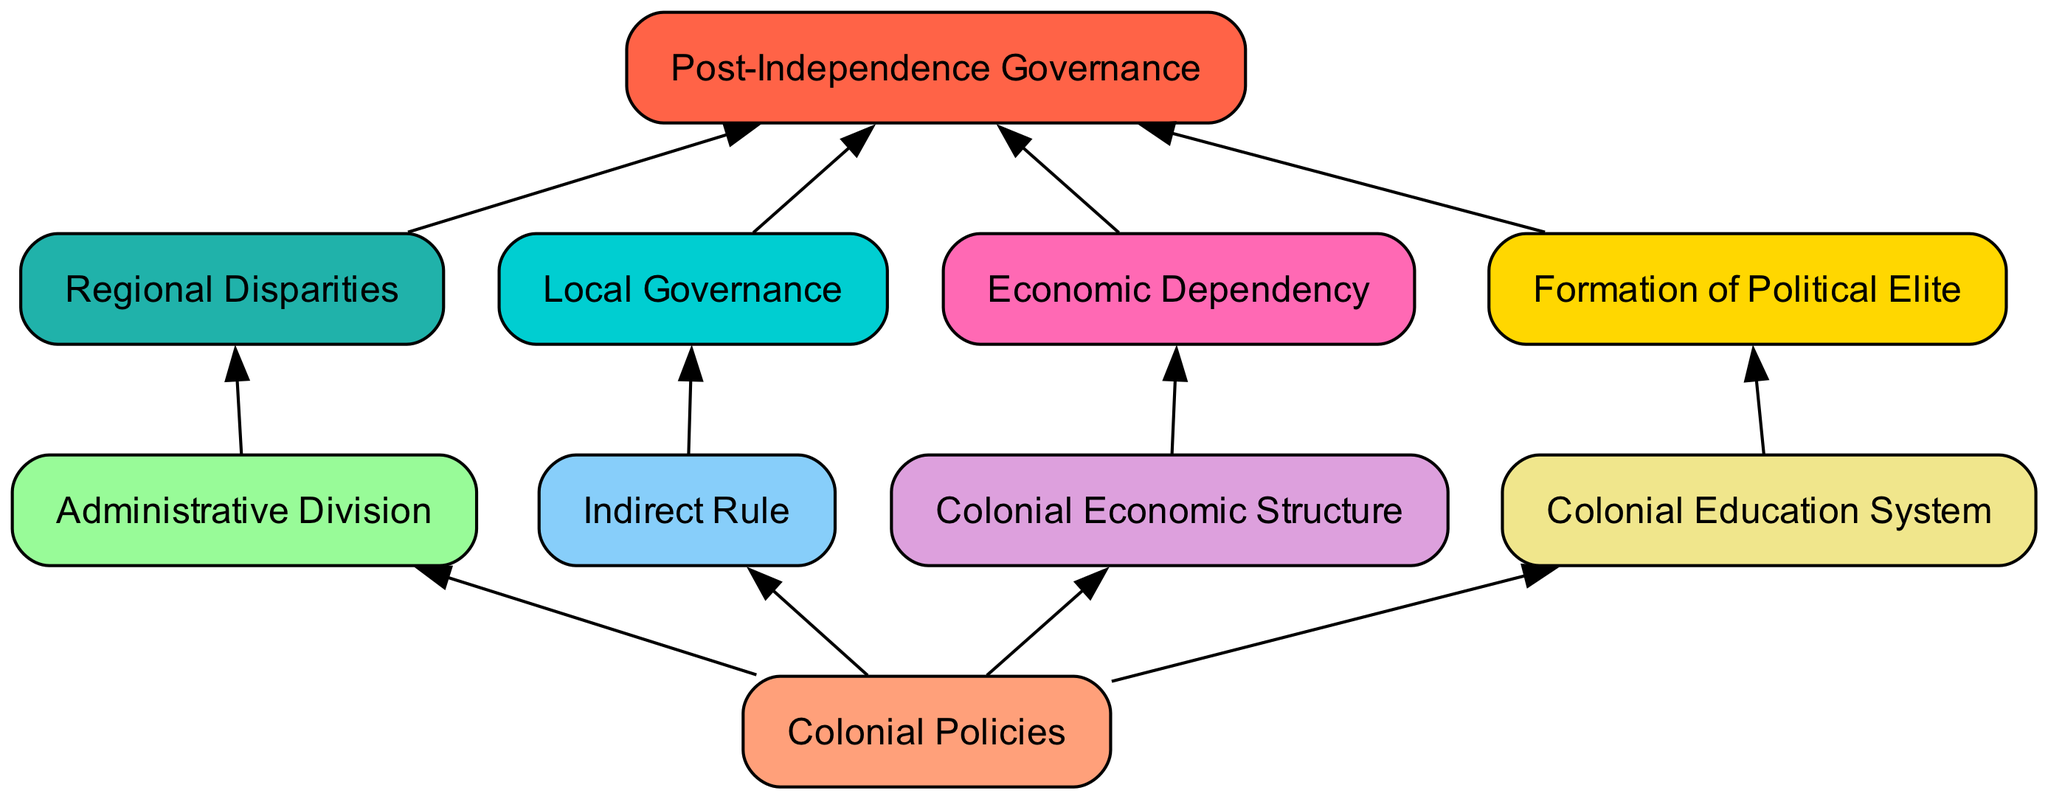What are the two main types of colonial policies represented? The two main types of colonial policies represented in the diagram are indirect rule and an economic structure based on groundnut exports. Both are connected to the overarching node of colonial policies.
Answer: indirect rule, economic structure How many nodes are in the diagram? By counting each distinct node in the diagram, which includes colonial policies, administrative division, indirect rule, economic structure, education system, post-independence governance, regional disparities, political elite, economic dependency, and local governance, we find there are ten nodes in total.
Answer: 10 What influences regional disparities? Regional disparities are influenced by the administrative division of the Gambian territory, which shows how the geographical organization can lead to uneven development across different regions.
Answer: administrative division Which node does the education system connect to? The education system connects to the formation of the political elite, indicating that the colonial education system played a significant role in shaping the local political class.
Answer: formation of political elite How does local governance impact post-independence governance? Local governance continues governance through local chiefs and regional leaders, creating a direct influence on post-independence governance by maintaining existing power structures that affect decision-making processes after independence.
Answer: local governance What might explain the economic dependency in post-independence Gambia? Economic dependency in post-independence Gambia is explained by the continued reliance on groundnut exports, as established by the colonial economic structure, leading to an economy that mirrors the colonial economy.
Answer: economic structure What is the relationship between colonial policies and post-independence governance? The relationship is direct; colonial policies establish foundational structures, such as economic dependency, regional disparities, and the political elite, which all subsequently impact post-independence governance.
Answer: direct relationship Which influences lead directly to post-independence governance? There are four influences that lead directly to post-independence governance: economic dependency, regional disparities, local governance, and the formation of the political elite, which together shape governance after independence.
Answer: economic dependency, regional disparities, local governance, formation of political elite What role does indirect rule play in local governance? Indirect rule establishes governance through local chiefs and regional leaders, indicating that this colonial policy directly contributes to the continuity of local governance structures after independence.
Answer: governance through local chiefs 